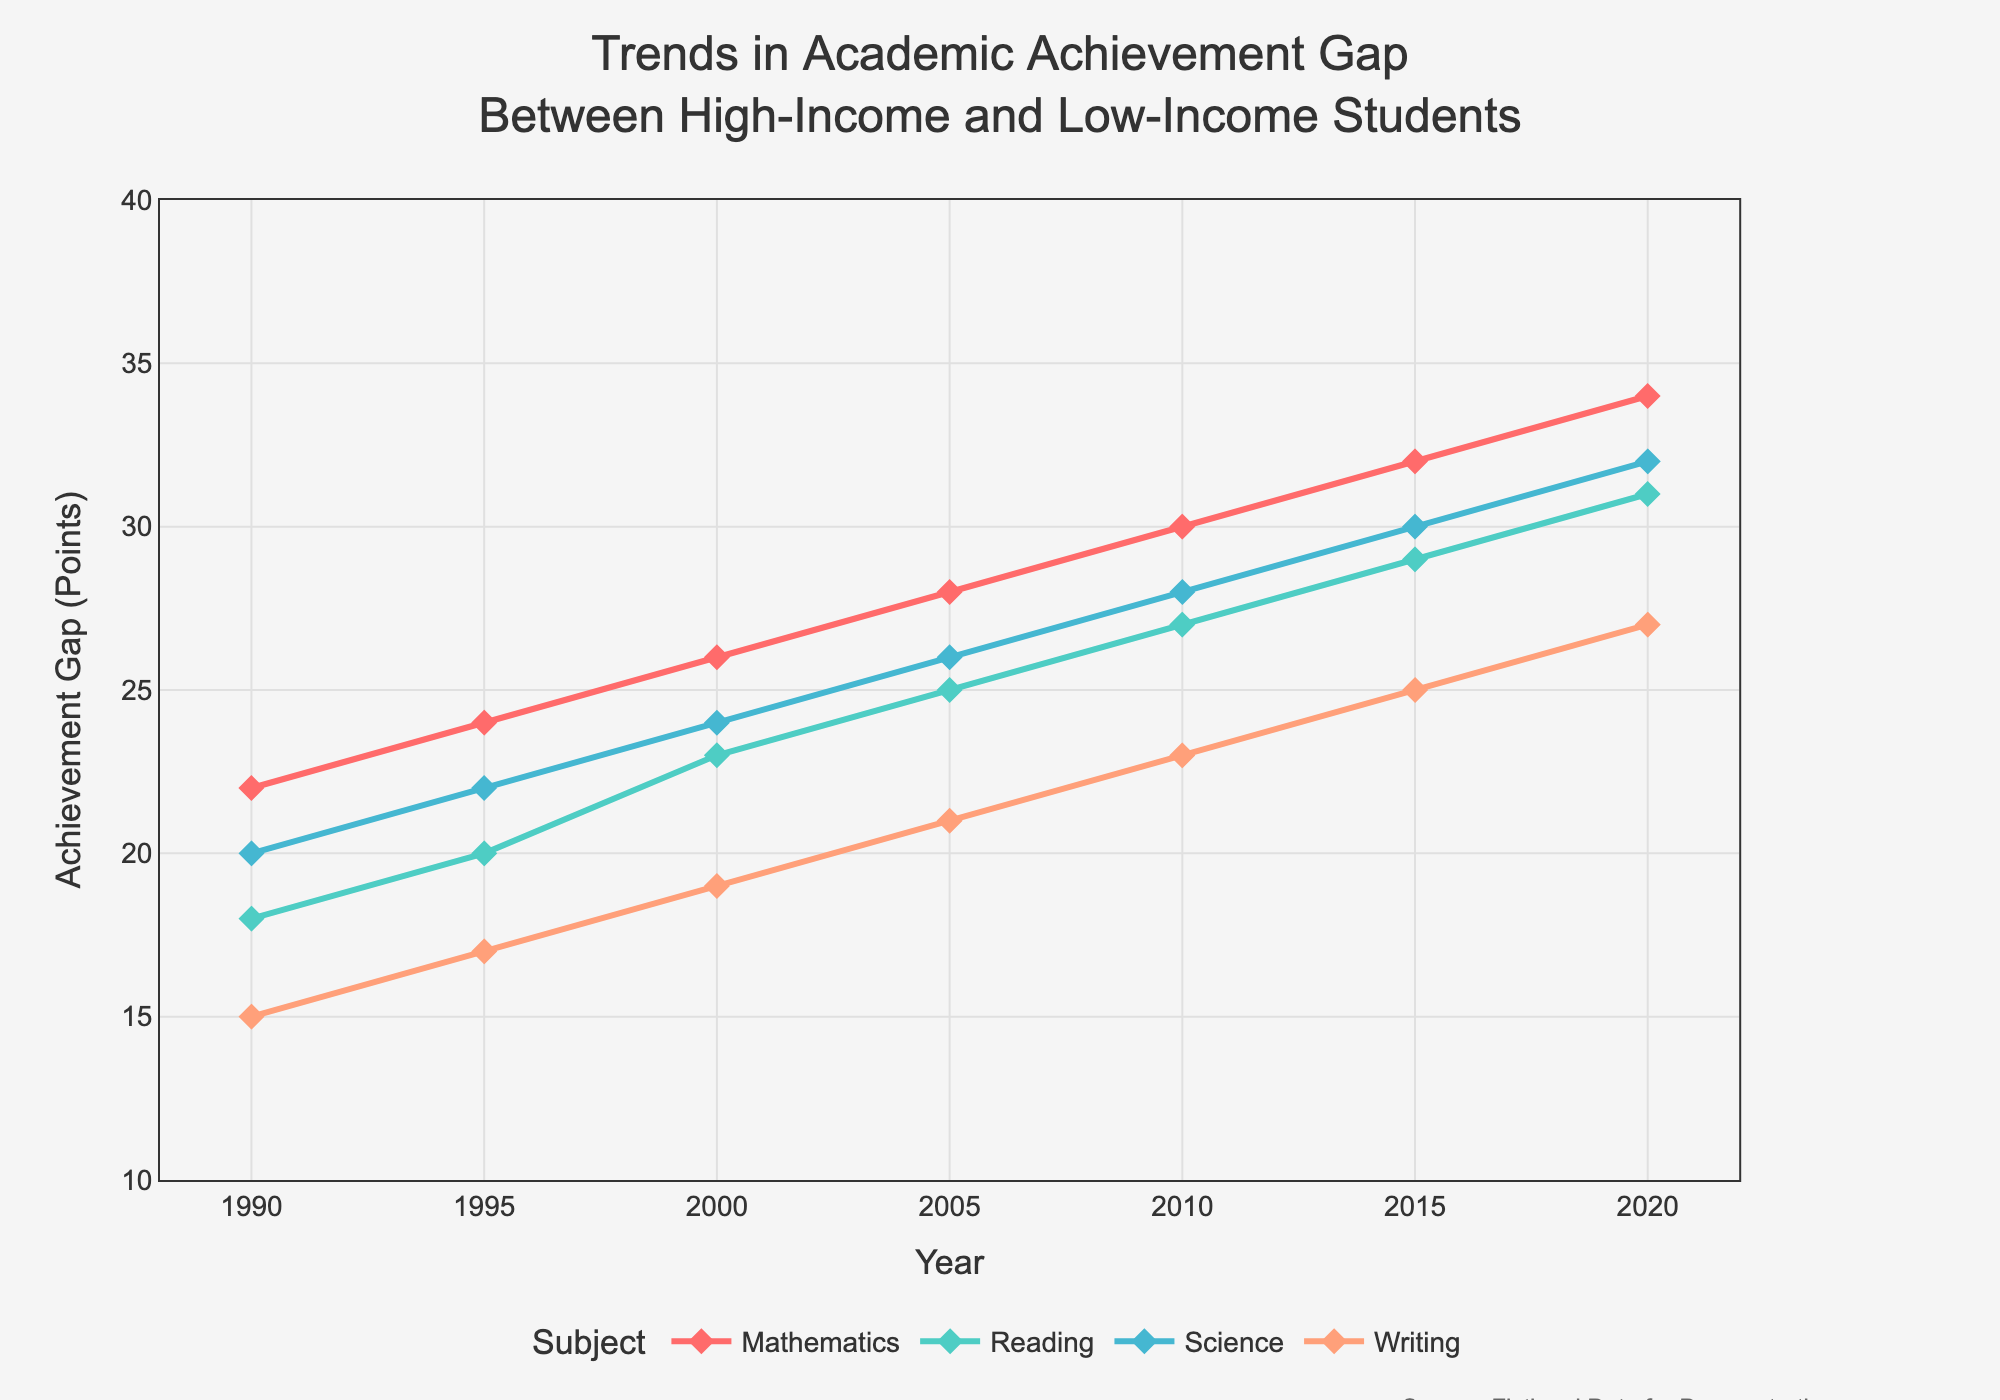What is the trend in the academic achievement gap for Mathematics from 1990 to 2020? The figure shows a line for Mathematics that starts at 22 points in 1990 and ends at 34 points in 2020. The line shows a steady increase over time.
Answer: Steady increase Which subject had the smallest achievement gap in 1990? By looking at the values in 1990 for each subject, the smallest value is 15 points for Writing.
Answer: Writing By how many points did the achievement gap in Reading change between 1995 and 2010? The achievement gap for Reading was 20 points in 1995 and increased to 27 points in 2010. The change is 27 - 20 = 7 points.
Answer: 7 points Compare the achievement gap in Science and Writing in 2000. Which was larger and by how much? In 2000, Science had an achievement gap of 24 points, and Writing had 19 points. The difference is 24 - 19 = 5 points. Science had a larger gap.
Answer: Science by 5 points What is the average achievement gap for all subjects in the year 2015? The values for 2015 are Mathematics: 32, Reading: 29, Science: 30, Writing: 25. Summing these gives 32 + 29 + 30 + 25 = 116, and the average is 116 / 4 = 29.
Answer: 29 points Which subject showed the greatest increase in the achievement gap from 1990 to 2020? Calculate the difference for each subject: Mathematics (34-22=12), Reading (31-18=13), Science (32-20=12), Writing (27-15=12). The greatest increase is in Reading with 13 points.
Answer: Reading How did the achievement gap in Writing change from 1990 to 2020? The achievement gap in Writing increased from 15 points in 1990 to 27 points in 2020, an overall increase of 12 points.
Answer: Increased by 12 points Is there any year where the achievement gap for all subjects is equal? By inspecting the visual lines and their values year by year, no year shows the same gap value across all subjects.
Answer: No Compare the visual attributes of the lines for Mathematics and Reading. How are they different in appearance and trend? The Mathematics line shows a steady increase and is colored in a different shade than Reading. Reading also increases but has a slightly lower starting and ending point than Mathematics.
Answer: Different colors, both increasing, Mathematics higher overall What can be inferred about the general trend of the achievement gaps across all subjects from 1990 to 2020? All four lines show a general upward trend, indicating that the achievement gaps in all subjects have increased over time.
Answer: Increasing trend 